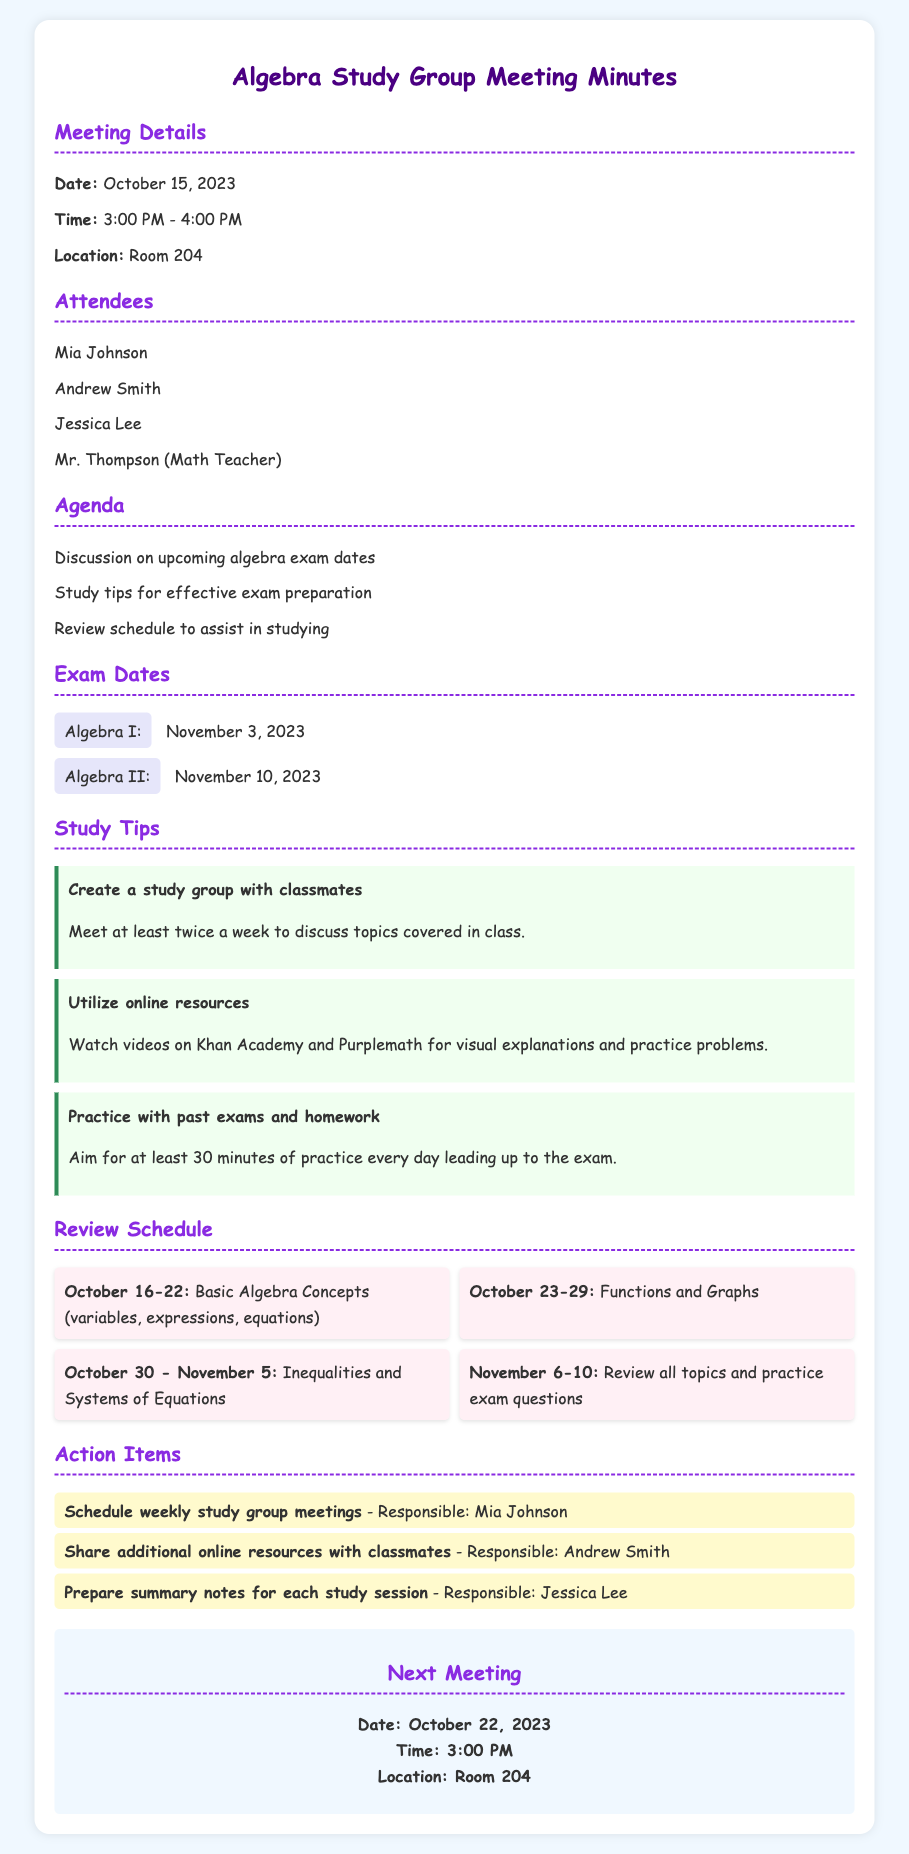What is the date of the Algebra I exam? The date of the Algebra I exam is provided in the document as November 3, 2023.
Answer: November 3, 2023 Who is responsible for sharing additional online resources? The person responsible for sharing additional online resources is mentioned in the action items section.
Answer: Andrew Smith What should you practice for at least 30 minutes every day? The document specifies that you should practice with past exams and homework for at least 30 minutes every day.
Answer: Past exams and homework Which week focuses on Functions and Graphs? The review schedule outlines the topics for specific weeks, identifying the week for Functions and Graphs.
Answer: October 23-29 What is one of the study tips mentioned? The document lists several study tips, one of which includes creating a study group with classmates.
Answer: Create a study group with classmates What is the location of the next meeting? The location of the next meeting can be found in the final section of the document, detailing the specifics of the next meeting.
Answer: Room 204 